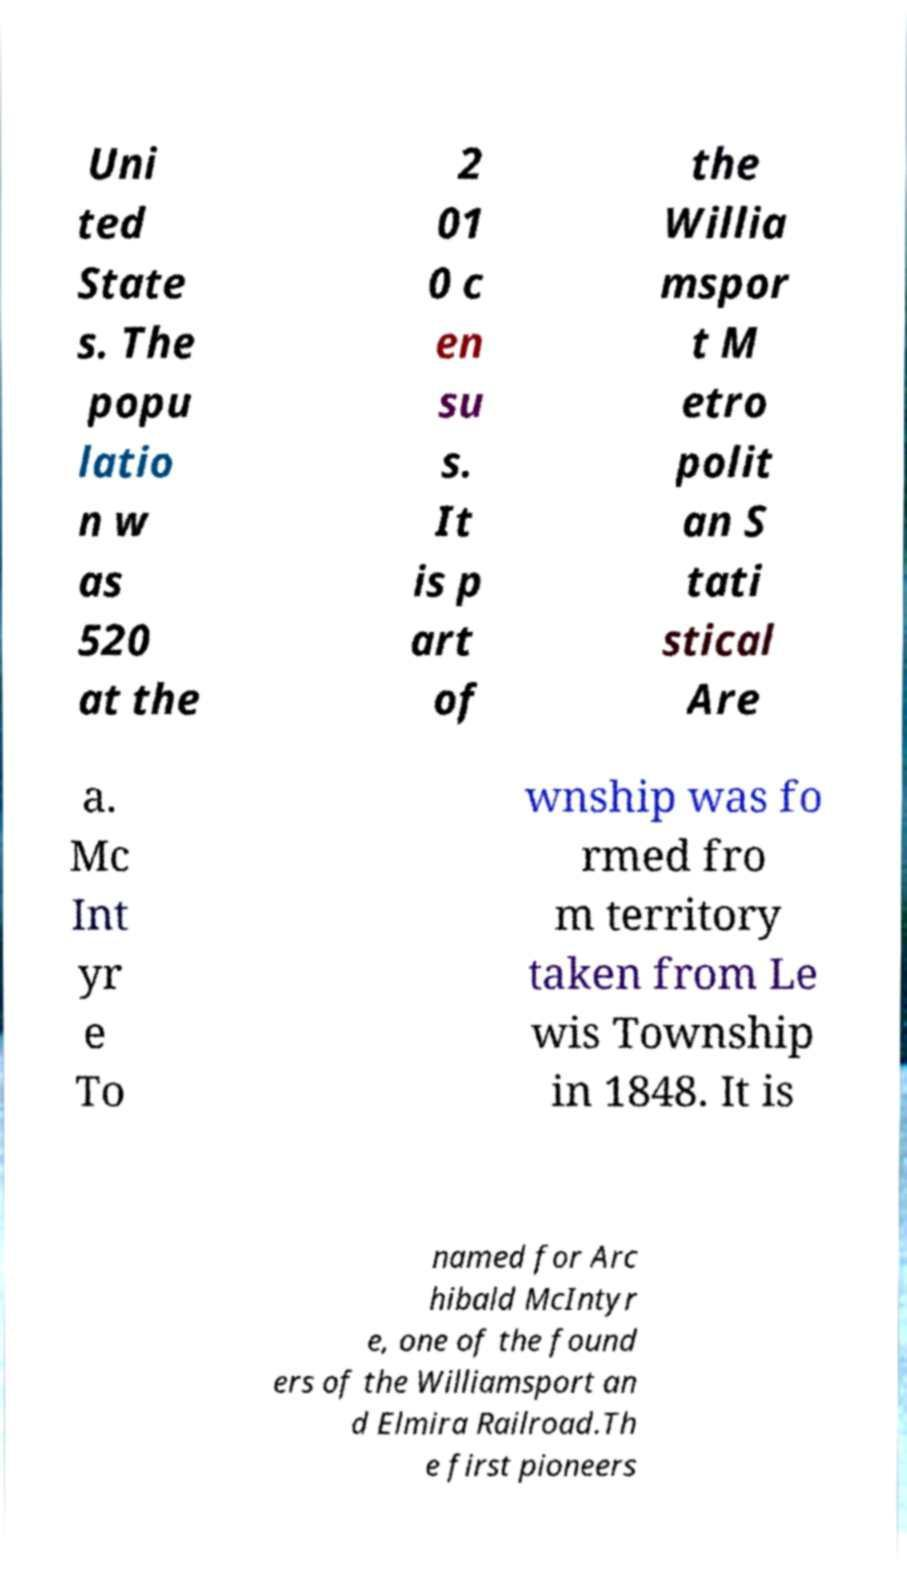There's text embedded in this image that I need extracted. Can you transcribe it verbatim? Uni ted State s. The popu latio n w as 520 at the 2 01 0 c en su s. It is p art of the Willia mspor t M etro polit an S tati stical Are a. Mc Int yr e To wnship was fo rmed fro m territory taken from Le wis Township in 1848. It is named for Arc hibald McIntyr e, one of the found ers of the Williamsport an d Elmira Railroad.Th e first pioneers 